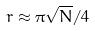<formula> <loc_0><loc_0><loc_500><loc_500>r \approx \pi \sqrt { N } / 4</formula> 